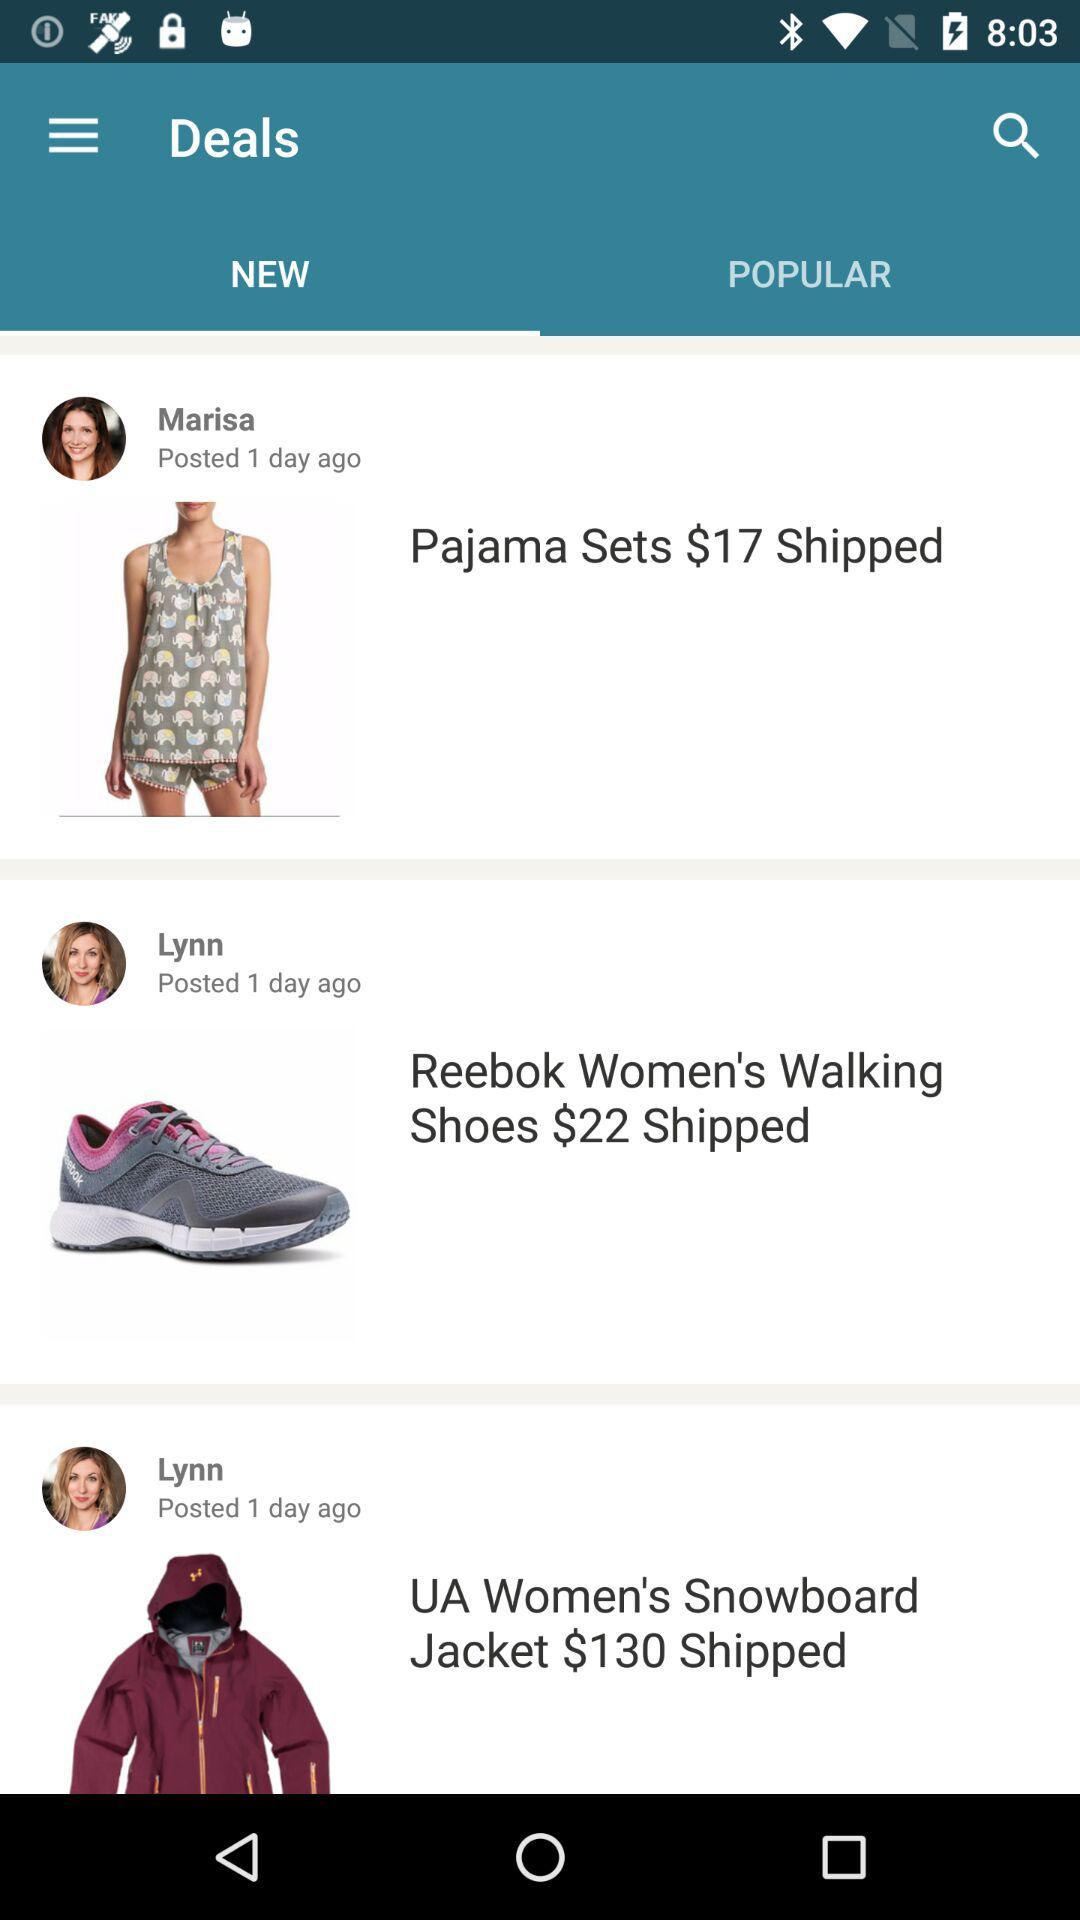How many days ago did Marisa post the deal? Marisa posted the deal 1 day ago. 